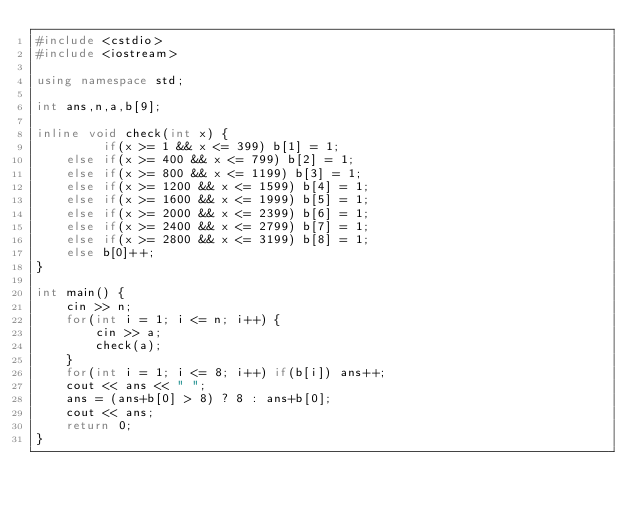Convert code to text. <code><loc_0><loc_0><loc_500><loc_500><_C++_>#include <cstdio>
#include <iostream>

using namespace std;

int ans,n,a,b[9];

inline void check(int x) {
		 if(x >= 1 && x <= 399) b[1] = 1;
	else if(x >= 400 && x <= 799) b[2] = 1;
	else if(x >= 800 && x <= 1199) b[3] = 1;
	else if(x >= 1200 && x <= 1599) b[4] = 1;
	else if(x >= 1600 && x <= 1999) b[5] = 1;
	else if(x >= 2000 && x <= 2399) b[6] = 1;
	else if(x >= 2400 && x <= 2799) b[7] = 1;
	else if(x >= 2800 && x <= 3199) b[8] = 1;
	else b[0]++;
}

int main() {
    cin >> n;
    for(int i = 1; i <= n; i++) {
    	cin >> a;
    	check(a);
    }
    for(int i = 1; i <= 8; i++) if(b[i]) ans++;
    cout << ans << " ";
    ans = (ans+b[0] > 8) ? 8 : ans+b[0];
    cout << ans;
    return 0;
}
</code> 